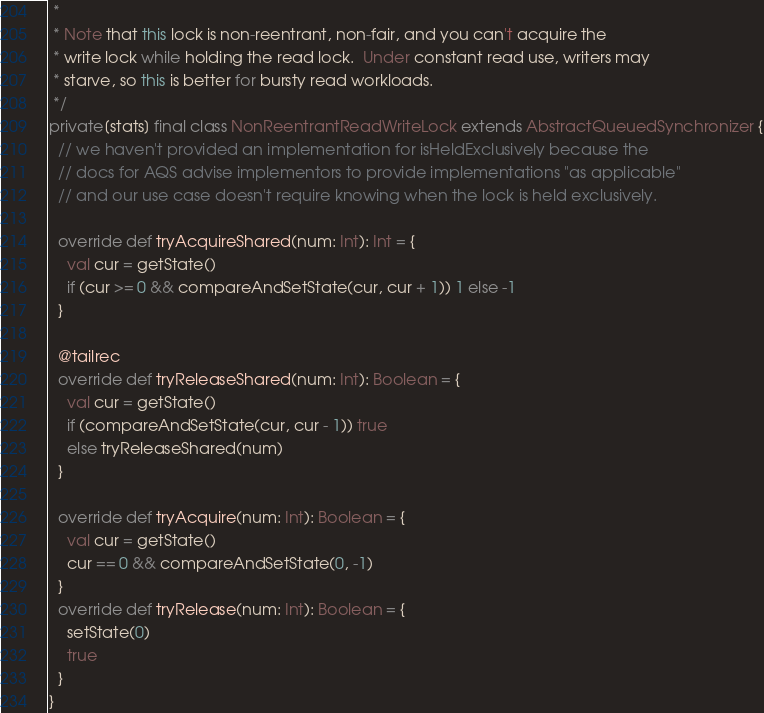Convert code to text. <code><loc_0><loc_0><loc_500><loc_500><_Scala_> *
 * Note that this lock is non-reentrant, non-fair, and you can't acquire the
 * write lock while holding the read lock.  Under constant read use, writers may
 * starve, so this is better for bursty read workloads.
 */
private[stats] final class NonReentrantReadWriteLock extends AbstractQueuedSynchronizer {
  // we haven't provided an implementation for isHeldExclusively because the
  // docs for AQS advise implementors to provide implementations "as applicable"
  // and our use case doesn't require knowing when the lock is held exclusively.

  override def tryAcquireShared(num: Int): Int = {
    val cur = getState()
    if (cur >= 0 && compareAndSetState(cur, cur + 1)) 1 else -1
  }

  @tailrec
  override def tryReleaseShared(num: Int): Boolean = {
    val cur = getState()
    if (compareAndSetState(cur, cur - 1)) true
    else tryReleaseShared(num)
  }

  override def tryAcquire(num: Int): Boolean = {
    val cur = getState()
    cur == 0 && compareAndSetState(0, -1)
  }
  override def tryRelease(num: Int): Boolean = {
    setState(0)
    true
  }
}
</code> 